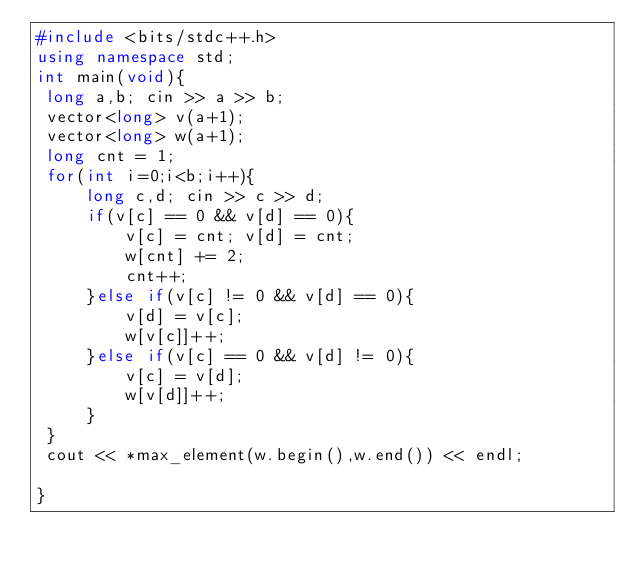Convert code to text. <code><loc_0><loc_0><loc_500><loc_500><_C++_>#include <bits/stdc++.h>
using namespace std;
int main(void){
 long a,b; cin >> a >> b;
 vector<long> v(a+1);
 vector<long> w(a+1);
 long cnt = 1;
 for(int i=0;i<b;i++){
     long c,d; cin >> c >> d;
     if(v[c] == 0 && v[d] == 0){
         v[c] = cnt; v[d] = cnt;
         w[cnt] += 2;
         cnt++;
     }else if(v[c] != 0 && v[d] == 0){
         v[d] = v[c];
         w[v[c]]++;
     }else if(v[c] == 0 && v[d] != 0){
         v[c] = v[d];
         w[v[d]]++;
     }
 }
 cout << *max_element(w.begin(),w.end()) << endl;

}</code> 